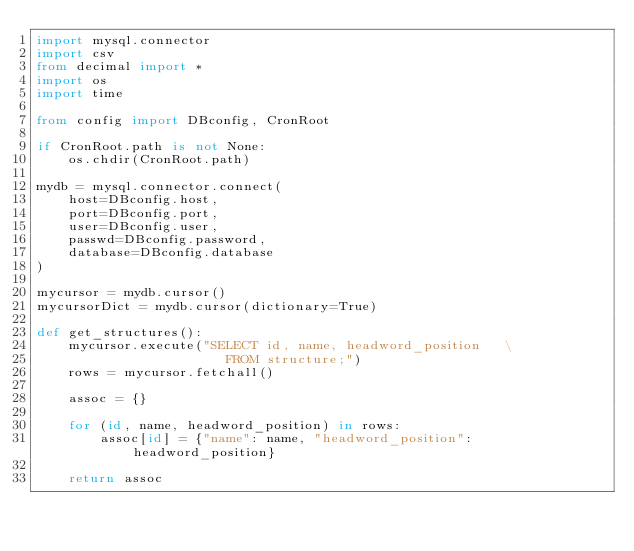Convert code to text. <code><loc_0><loc_0><loc_500><loc_500><_Python_>import mysql.connector
import csv
from decimal import *
import os
import time

from config import DBconfig, CronRoot

if CronRoot.path is not None:
    os.chdir(CronRoot.path)

mydb = mysql.connector.connect(
    host=DBconfig.host,
    port=DBconfig.port,
    user=DBconfig.user,
    passwd=DBconfig.password,
    database=DBconfig.database
)

mycursor = mydb.cursor()
mycursorDict = mydb.cursor(dictionary=True)

def get_structures():
    mycursor.execute("SELECT id, name, headword_position   \
                        FROM structure;")
    rows = mycursor.fetchall()

    assoc = {}

    for (id, name, headword_position) in rows:
        assoc[id] = {"name": name, "headword_position": headword_position}

    return assoc
</code> 